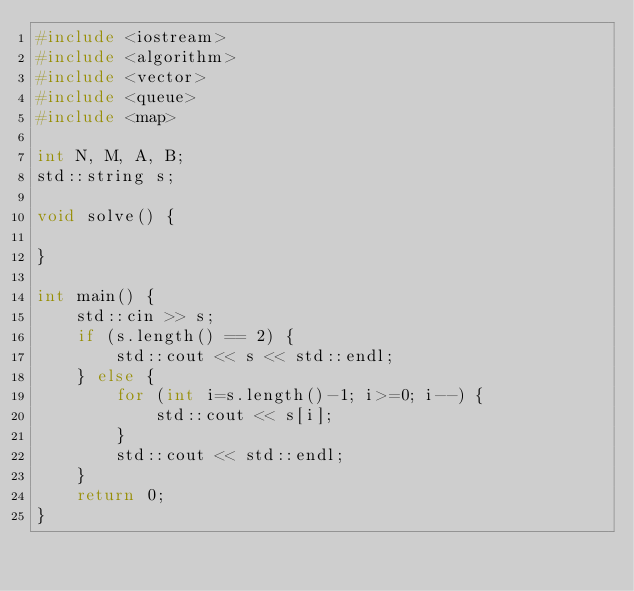<code> <loc_0><loc_0><loc_500><loc_500><_C++_>#include <iostream>
#include <algorithm>
#include <vector>
#include <queue>
#include <map>

int N, M, A, B;
std::string s;

void solve() {

}

int main() {
    std::cin >> s;
    if (s.length() == 2) {
        std::cout << s << std::endl;
    } else {
        for (int i=s.length()-1; i>=0; i--) {
            std::cout << s[i];
        }
        std::cout << std::endl;
    }
    return 0;
}
</code> 